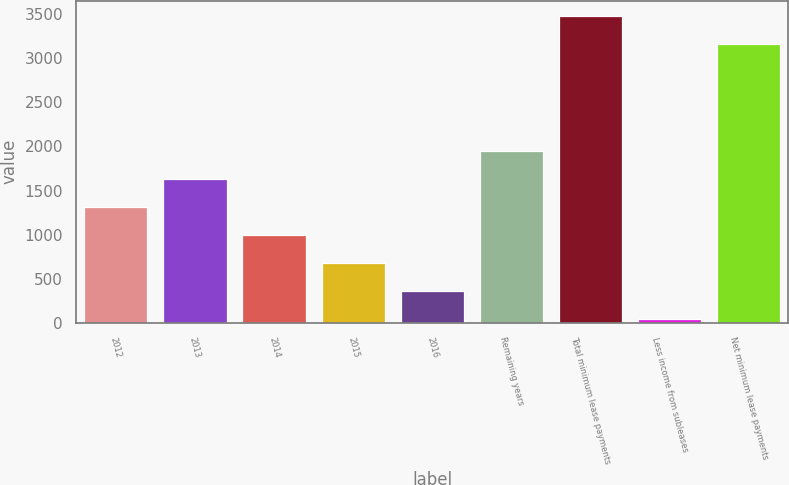Convert chart. <chart><loc_0><loc_0><loc_500><loc_500><bar_chart><fcel>2012<fcel>2013<fcel>2014<fcel>2015<fcel>2016<fcel>Remaining years<fcel>Total minimum lease payments<fcel>Less income from subleases<fcel>Net minimum lease payments<nl><fcel>1312.2<fcel>1628.5<fcel>995.9<fcel>679.6<fcel>363.3<fcel>1944.8<fcel>3479.3<fcel>47<fcel>3163<nl></chart> 